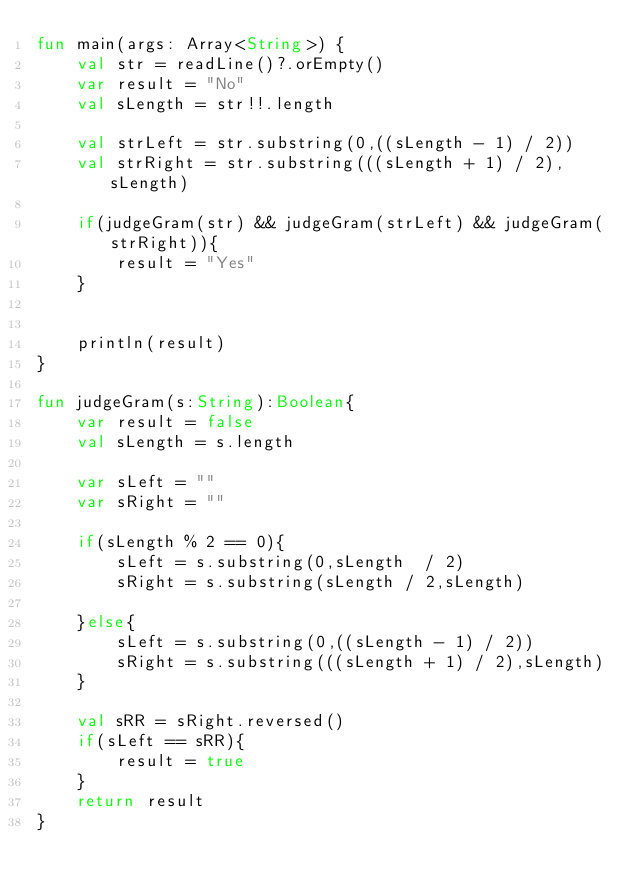Convert code to text. <code><loc_0><loc_0><loc_500><loc_500><_Kotlin_>fun main(args: Array<String>) {
    val str = readLine()?.orEmpty()
    var result = "No"
    val sLength = str!!.length

    val strLeft = str.substring(0,((sLength - 1) / 2))
    val strRight = str.substring(((sLength + 1) / 2),sLength)

    if(judgeGram(str) && judgeGram(strLeft) && judgeGram(strRight)){
        result = "Yes"
    }

    
    println(result)
}

fun judgeGram(s:String):Boolean{
    var result = false
    val sLength = s.length

    var sLeft = ""
    var sRight = ""

    if(sLength % 2 == 0){
        sLeft = s.substring(0,sLength  / 2)
        sRight = s.substring(sLength / 2,sLength)

    }else{
        sLeft = s.substring(0,((sLength - 1) / 2))
        sRight = s.substring(((sLength + 1) / 2),sLength)
    }

    val sRR = sRight.reversed()
    if(sLeft == sRR){
        result = true
    }
    return result
}</code> 